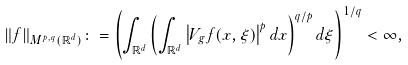Convert formula to latex. <formula><loc_0><loc_0><loc_500><loc_500>\| f \| _ { M ^ { p , q } ( { \mathbb { R } ^ { d } } ) } \colon = \left ( \int _ { { \mathbb { R } ^ { d } } } \left ( \int _ { { \mathbb { R } ^ { d } } } \left | V _ { g } f ( x , \xi ) \right | ^ { p } d x \right ) ^ { q / p } d \xi \right ) ^ { 1 / q } < \infty ,</formula> 